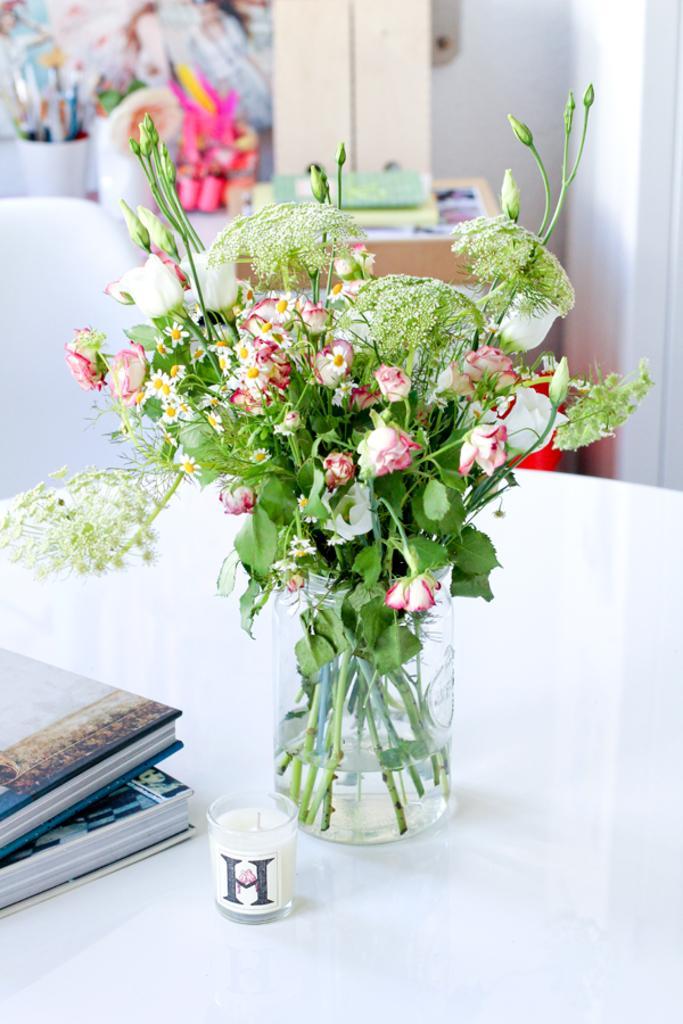Could you give a brief overview of what you see in this image? In this picture I can see there is a flower vase and there are some flowers in it. There is a candle, books placed on the table and in the backdrop there is a painting and there is a wall. 